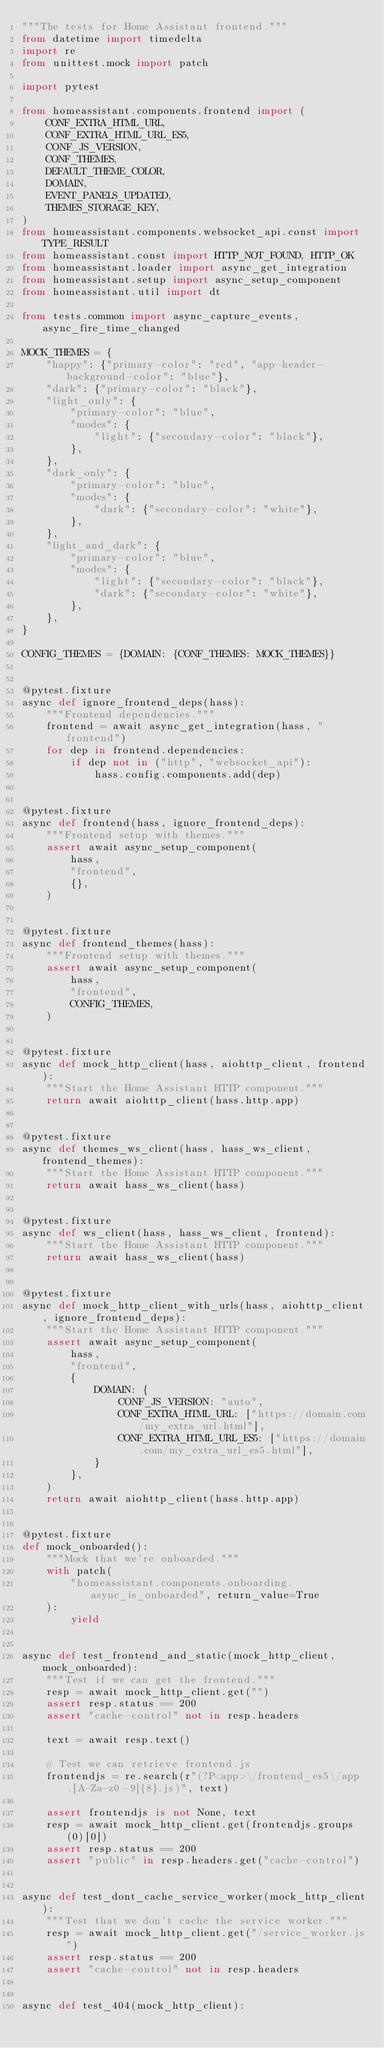Convert code to text. <code><loc_0><loc_0><loc_500><loc_500><_Python_>"""The tests for Home Assistant frontend."""
from datetime import timedelta
import re
from unittest.mock import patch

import pytest

from homeassistant.components.frontend import (
    CONF_EXTRA_HTML_URL,
    CONF_EXTRA_HTML_URL_ES5,
    CONF_JS_VERSION,
    CONF_THEMES,
    DEFAULT_THEME_COLOR,
    DOMAIN,
    EVENT_PANELS_UPDATED,
    THEMES_STORAGE_KEY,
)
from homeassistant.components.websocket_api.const import TYPE_RESULT
from homeassistant.const import HTTP_NOT_FOUND, HTTP_OK
from homeassistant.loader import async_get_integration
from homeassistant.setup import async_setup_component
from homeassistant.util import dt

from tests.common import async_capture_events, async_fire_time_changed

MOCK_THEMES = {
    "happy": {"primary-color": "red", "app-header-background-color": "blue"},
    "dark": {"primary-color": "black"},
    "light_only": {
        "primary-color": "blue",
        "modes": {
            "light": {"secondary-color": "black"},
        },
    },
    "dark_only": {
        "primary-color": "blue",
        "modes": {
            "dark": {"secondary-color": "white"},
        },
    },
    "light_and_dark": {
        "primary-color": "blue",
        "modes": {
            "light": {"secondary-color": "black"},
            "dark": {"secondary-color": "white"},
        },
    },
}

CONFIG_THEMES = {DOMAIN: {CONF_THEMES: MOCK_THEMES}}


@pytest.fixture
async def ignore_frontend_deps(hass):
    """Frontend dependencies."""
    frontend = await async_get_integration(hass, "frontend")
    for dep in frontend.dependencies:
        if dep not in ("http", "websocket_api"):
            hass.config.components.add(dep)


@pytest.fixture
async def frontend(hass, ignore_frontend_deps):
    """Frontend setup with themes."""
    assert await async_setup_component(
        hass,
        "frontend",
        {},
    )


@pytest.fixture
async def frontend_themes(hass):
    """Frontend setup with themes."""
    assert await async_setup_component(
        hass,
        "frontend",
        CONFIG_THEMES,
    )


@pytest.fixture
async def mock_http_client(hass, aiohttp_client, frontend):
    """Start the Home Assistant HTTP component."""
    return await aiohttp_client(hass.http.app)


@pytest.fixture
async def themes_ws_client(hass, hass_ws_client, frontend_themes):
    """Start the Home Assistant HTTP component."""
    return await hass_ws_client(hass)


@pytest.fixture
async def ws_client(hass, hass_ws_client, frontend):
    """Start the Home Assistant HTTP component."""
    return await hass_ws_client(hass)


@pytest.fixture
async def mock_http_client_with_urls(hass, aiohttp_client, ignore_frontend_deps):
    """Start the Home Assistant HTTP component."""
    assert await async_setup_component(
        hass,
        "frontend",
        {
            DOMAIN: {
                CONF_JS_VERSION: "auto",
                CONF_EXTRA_HTML_URL: ["https://domain.com/my_extra_url.html"],
                CONF_EXTRA_HTML_URL_ES5: ["https://domain.com/my_extra_url_es5.html"],
            }
        },
    )
    return await aiohttp_client(hass.http.app)


@pytest.fixture
def mock_onboarded():
    """Mock that we're onboarded."""
    with patch(
        "homeassistant.components.onboarding.async_is_onboarded", return_value=True
    ):
        yield


async def test_frontend_and_static(mock_http_client, mock_onboarded):
    """Test if we can get the frontend."""
    resp = await mock_http_client.get("")
    assert resp.status == 200
    assert "cache-control" not in resp.headers

    text = await resp.text()

    # Test we can retrieve frontend.js
    frontendjs = re.search(r"(?P<app>\/frontend_es5\/app.[A-Za-z0-9]{8}.js)", text)

    assert frontendjs is not None, text
    resp = await mock_http_client.get(frontendjs.groups(0)[0])
    assert resp.status == 200
    assert "public" in resp.headers.get("cache-control")


async def test_dont_cache_service_worker(mock_http_client):
    """Test that we don't cache the service worker."""
    resp = await mock_http_client.get("/service_worker.js")
    assert resp.status == 200
    assert "cache-control" not in resp.headers


async def test_404(mock_http_client):</code> 